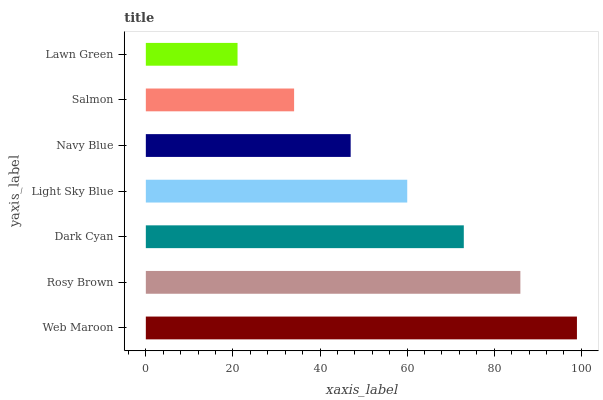Is Lawn Green the minimum?
Answer yes or no. Yes. Is Web Maroon the maximum?
Answer yes or no. Yes. Is Rosy Brown the minimum?
Answer yes or no. No. Is Rosy Brown the maximum?
Answer yes or no. No. Is Web Maroon greater than Rosy Brown?
Answer yes or no. Yes. Is Rosy Brown less than Web Maroon?
Answer yes or no. Yes. Is Rosy Brown greater than Web Maroon?
Answer yes or no. No. Is Web Maroon less than Rosy Brown?
Answer yes or no. No. Is Light Sky Blue the high median?
Answer yes or no. Yes. Is Light Sky Blue the low median?
Answer yes or no. Yes. Is Lawn Green the high median?
Answer yes or no. No. Is Navy Blue the low median?
Answer yes or no. No. 